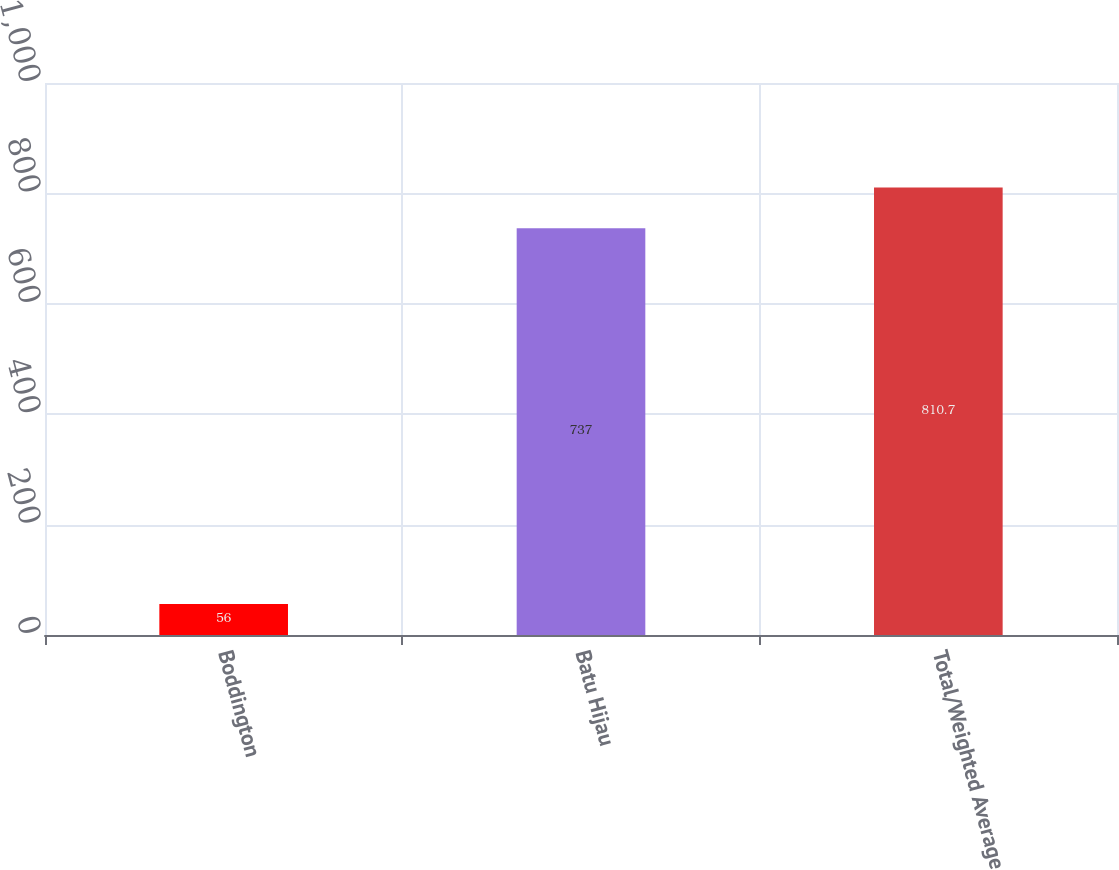Convert chart to OTSL. <chart><loc_0><loc_0><loc_500><loc_500><bar_chart><fcel>Boddington<fcel>Batu Hijau<fcel>Total/Weighted Average<nl><fcel>56<fcel>737<fcel>810.7<nl></chart> 